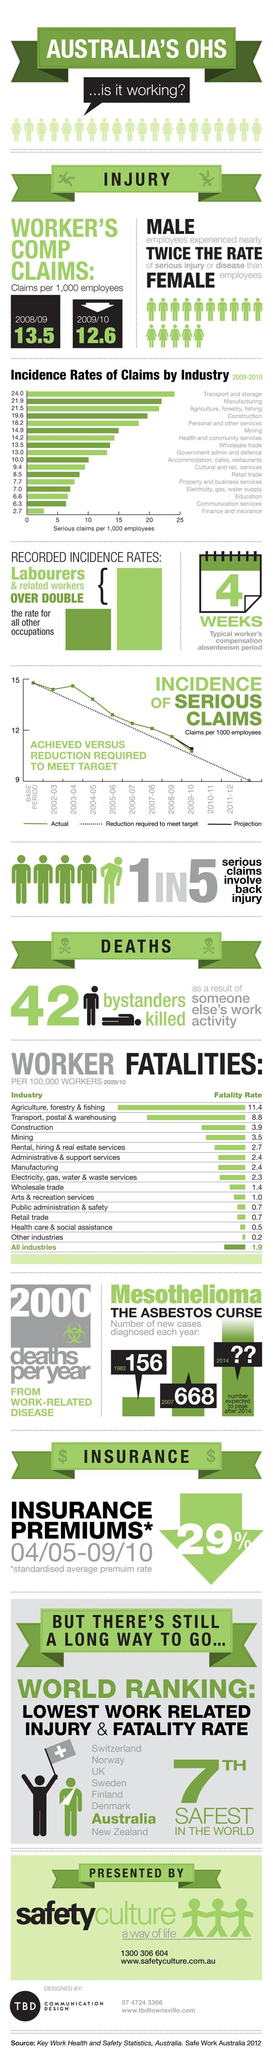List a handful of essential elements in this visual. According to data from 2009/10, the fatality rates for two industries were 0.7 per 100,000 workers. These industries were Public administration and safety, and Retail trade. The number of workers' compensation claims per 1,000 employees decreased from 2008/09 to 2009/10, with a decrease from 0.9 to 0. There is one source listed at the bottom. The agriculture, forestry, and fishing industry has the third highest incidence rates of claims, according to the data. The incidence rate of claims in finance and insurance, as well as communication services, per 1000 employees in 2009-2010 was X. 